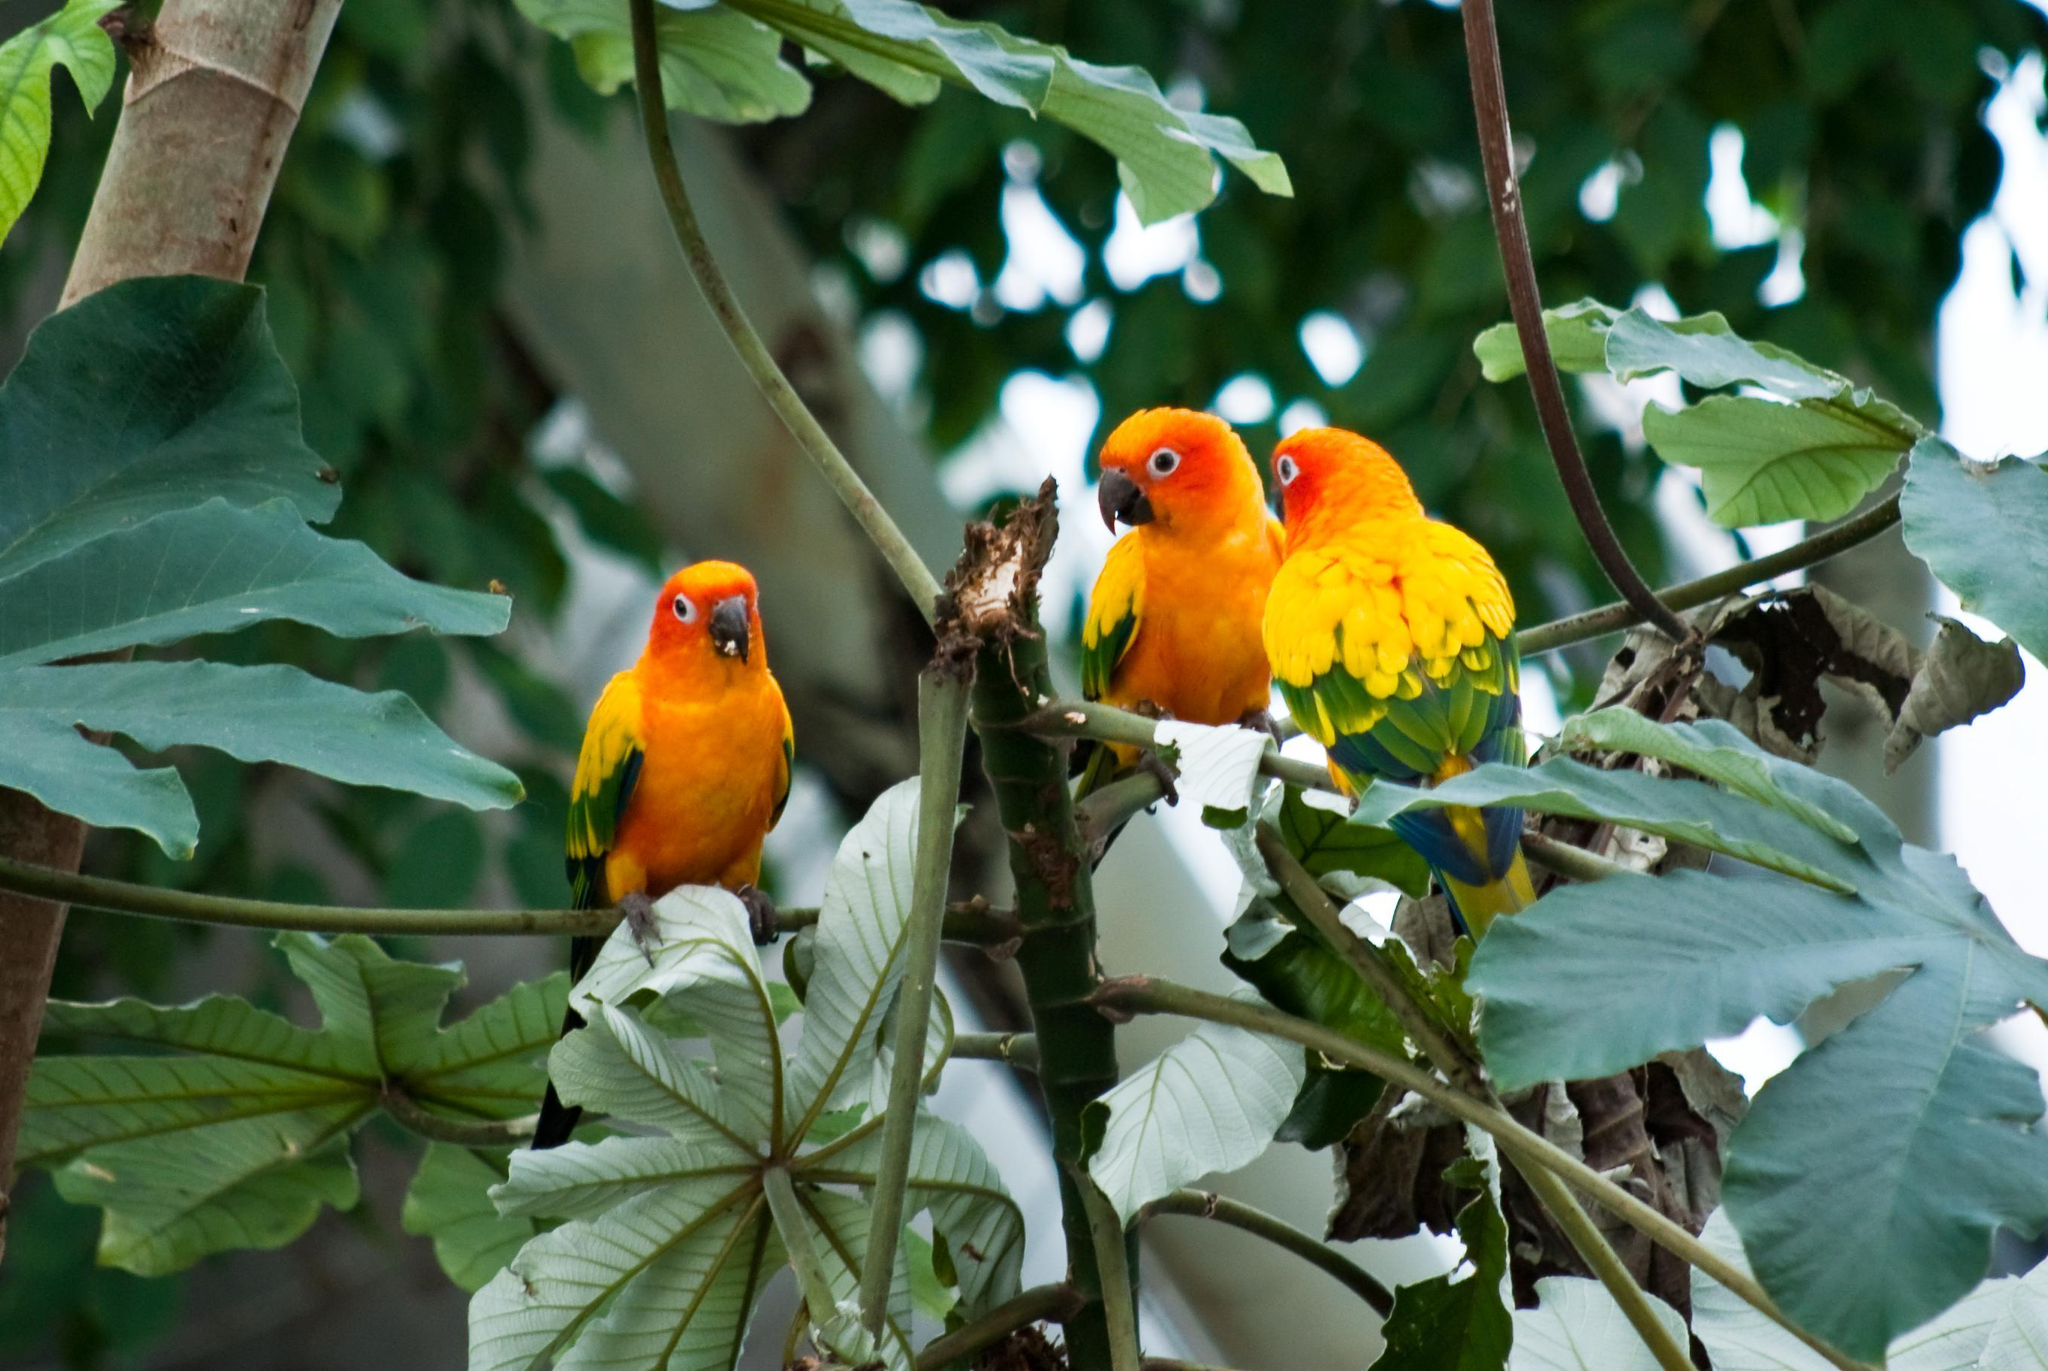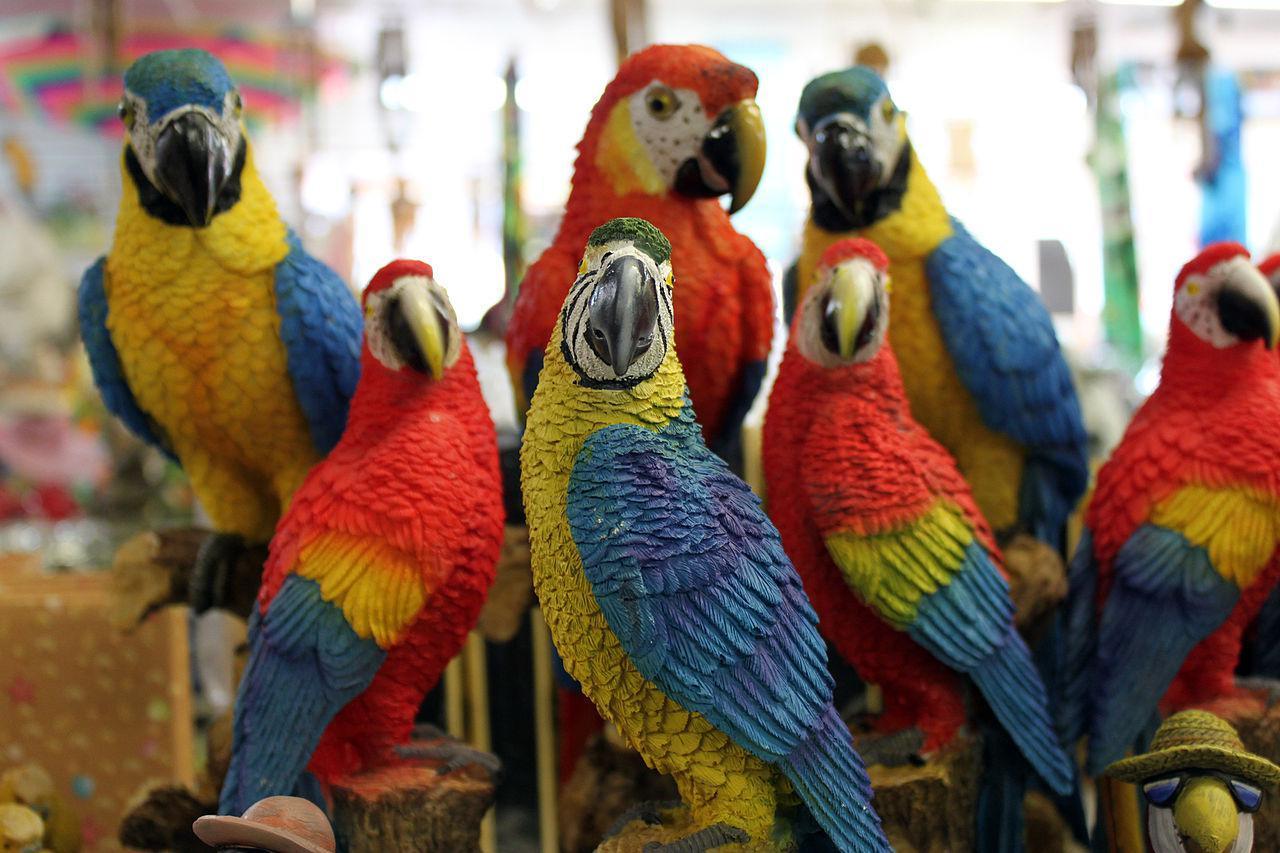The first image is the image on the left, the second image is the image on the right. Evaluate the accuracy of this statement regarding the images: "At least one image contains no more than 3 birds.". Is it true? Answer yes or no. Yes. 